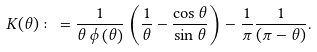Convert formula to latex. <formula><loc_0><loc_0><loc_500><loc_500>K ( \theta ) \colon = \frac { 1 } { \theta \, \phi \left ( \theta \right ) } \left ( \frac { 1 } { \theta } - \frac { \cos { \theta } } { \sin { \theta } } \right ) - \frac { 1 } { \pi } \frac { 1 } { ( \pi - \theta ) } .</formula> 